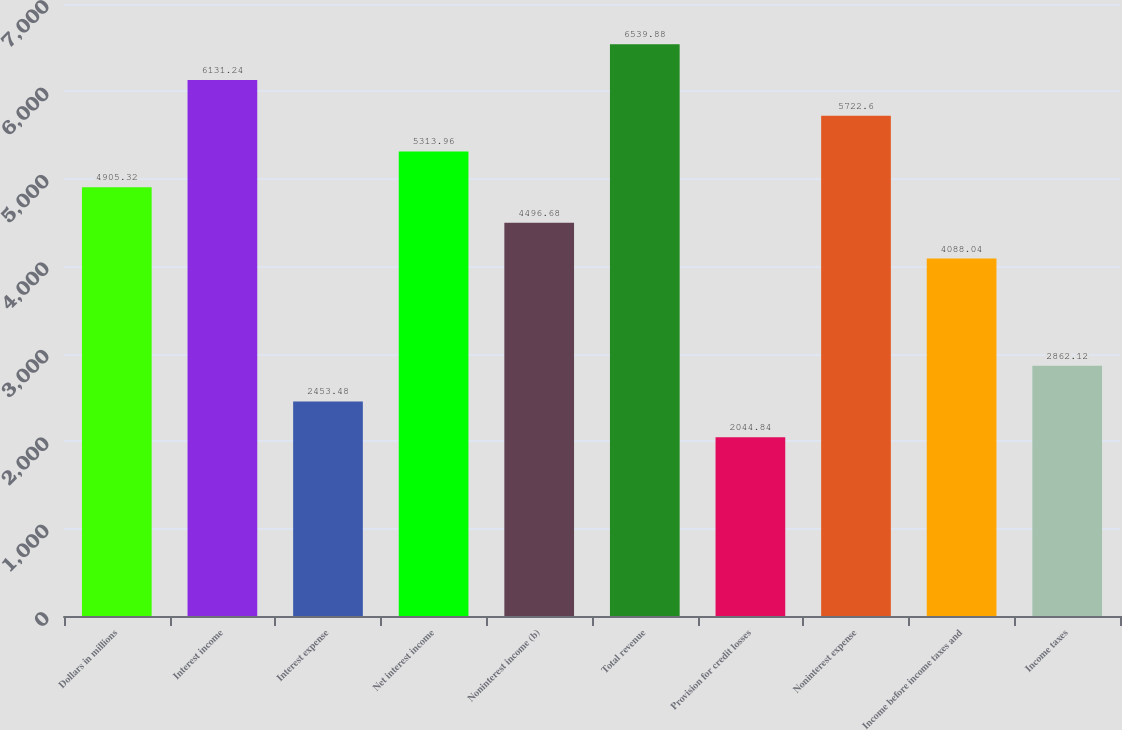<chart> <loc_0><loc_0><loc_500><loc_500><bar_chart><fcel>Dollars in millions<fcel>Interest income<fcel>Interest expense<fcel>Net interest income<fcel>Noninterest income (b)<fcel>Total revenue<fcel>Provision for credit losses<fcel>Noninterest expense<fcel>Income before income taxes and<fcel>Income taxes<nl><fcel>4905.32<fcel>6131.24<fcel>2453.48<fcel>5313.96<fcel>4496.68<fcel>6539.88<fcel>2044.84<fcel>5722.6<fcel>4088.04<fcel>2862.12<nl></chart> 